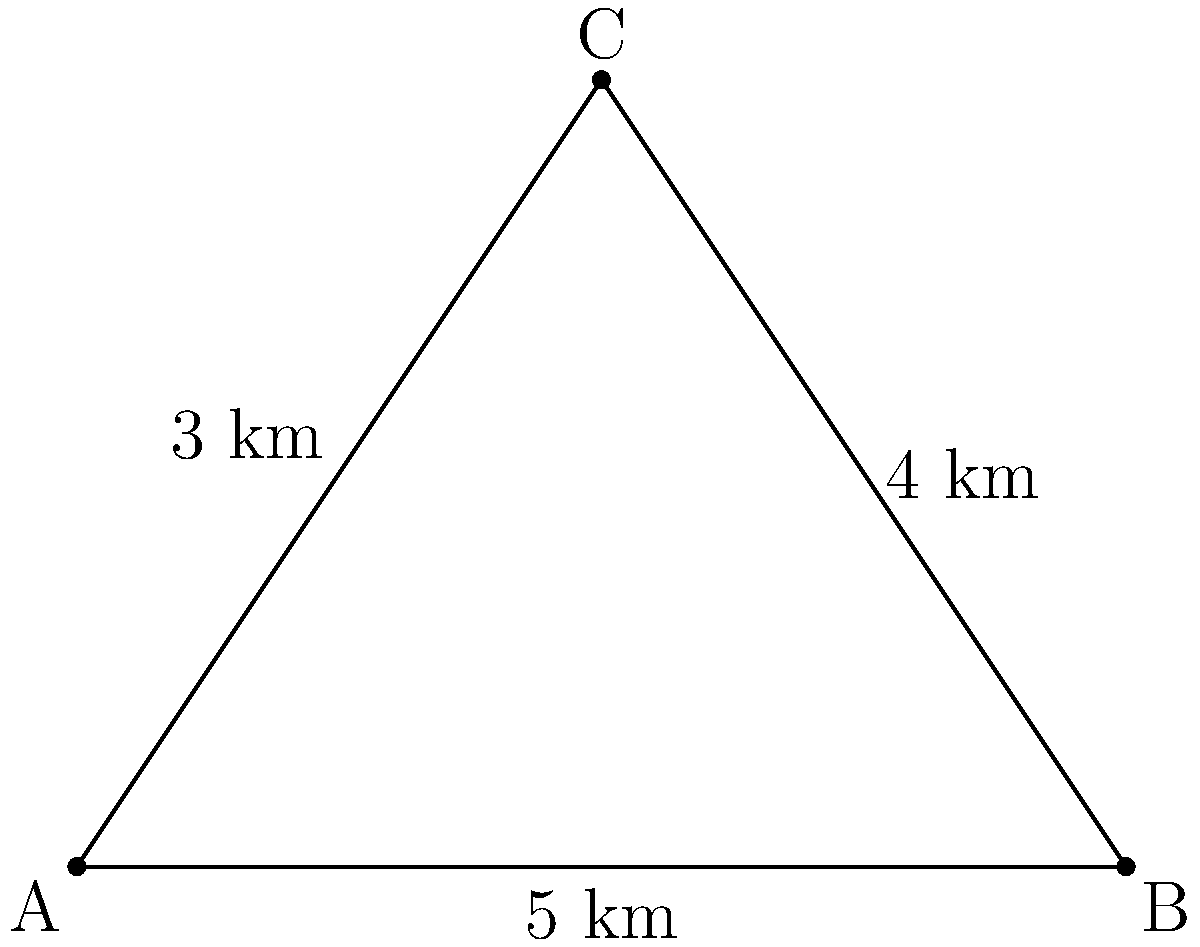In an offshore oil field, three platforms (A, B, and C) need to be connected by subsea cables. The distances between the platforms are: A to B is 5 km, B to C is 4 km, and A to C is 3 km. What is the minimum total length of cable needed to connect all three platforms? To find the minimum total length of cable needed, we should follow these steps:

1. Recognize that this is a minimum spanning tree problem.
2. In a three-node configuration, the minimum spanning tree will always exclude the longest edge.
3. Compare the lengths of the three edges:
   AB = 5 km
   BC = 4 km
   AC = 3 km
4. The longest edge is AB (5 km), so we exclude this one.
5. The minimum spanning tree will consist of edges BC and AC.
6. Calculate the total length:
   $$ \text{Total length} = BC + AC = 4 \text{ km} + 3 \text{ km} = 7 \text{ km} $$

Therefore, the minimum total length of cable needed is 7 km.
Answer: 7 km 